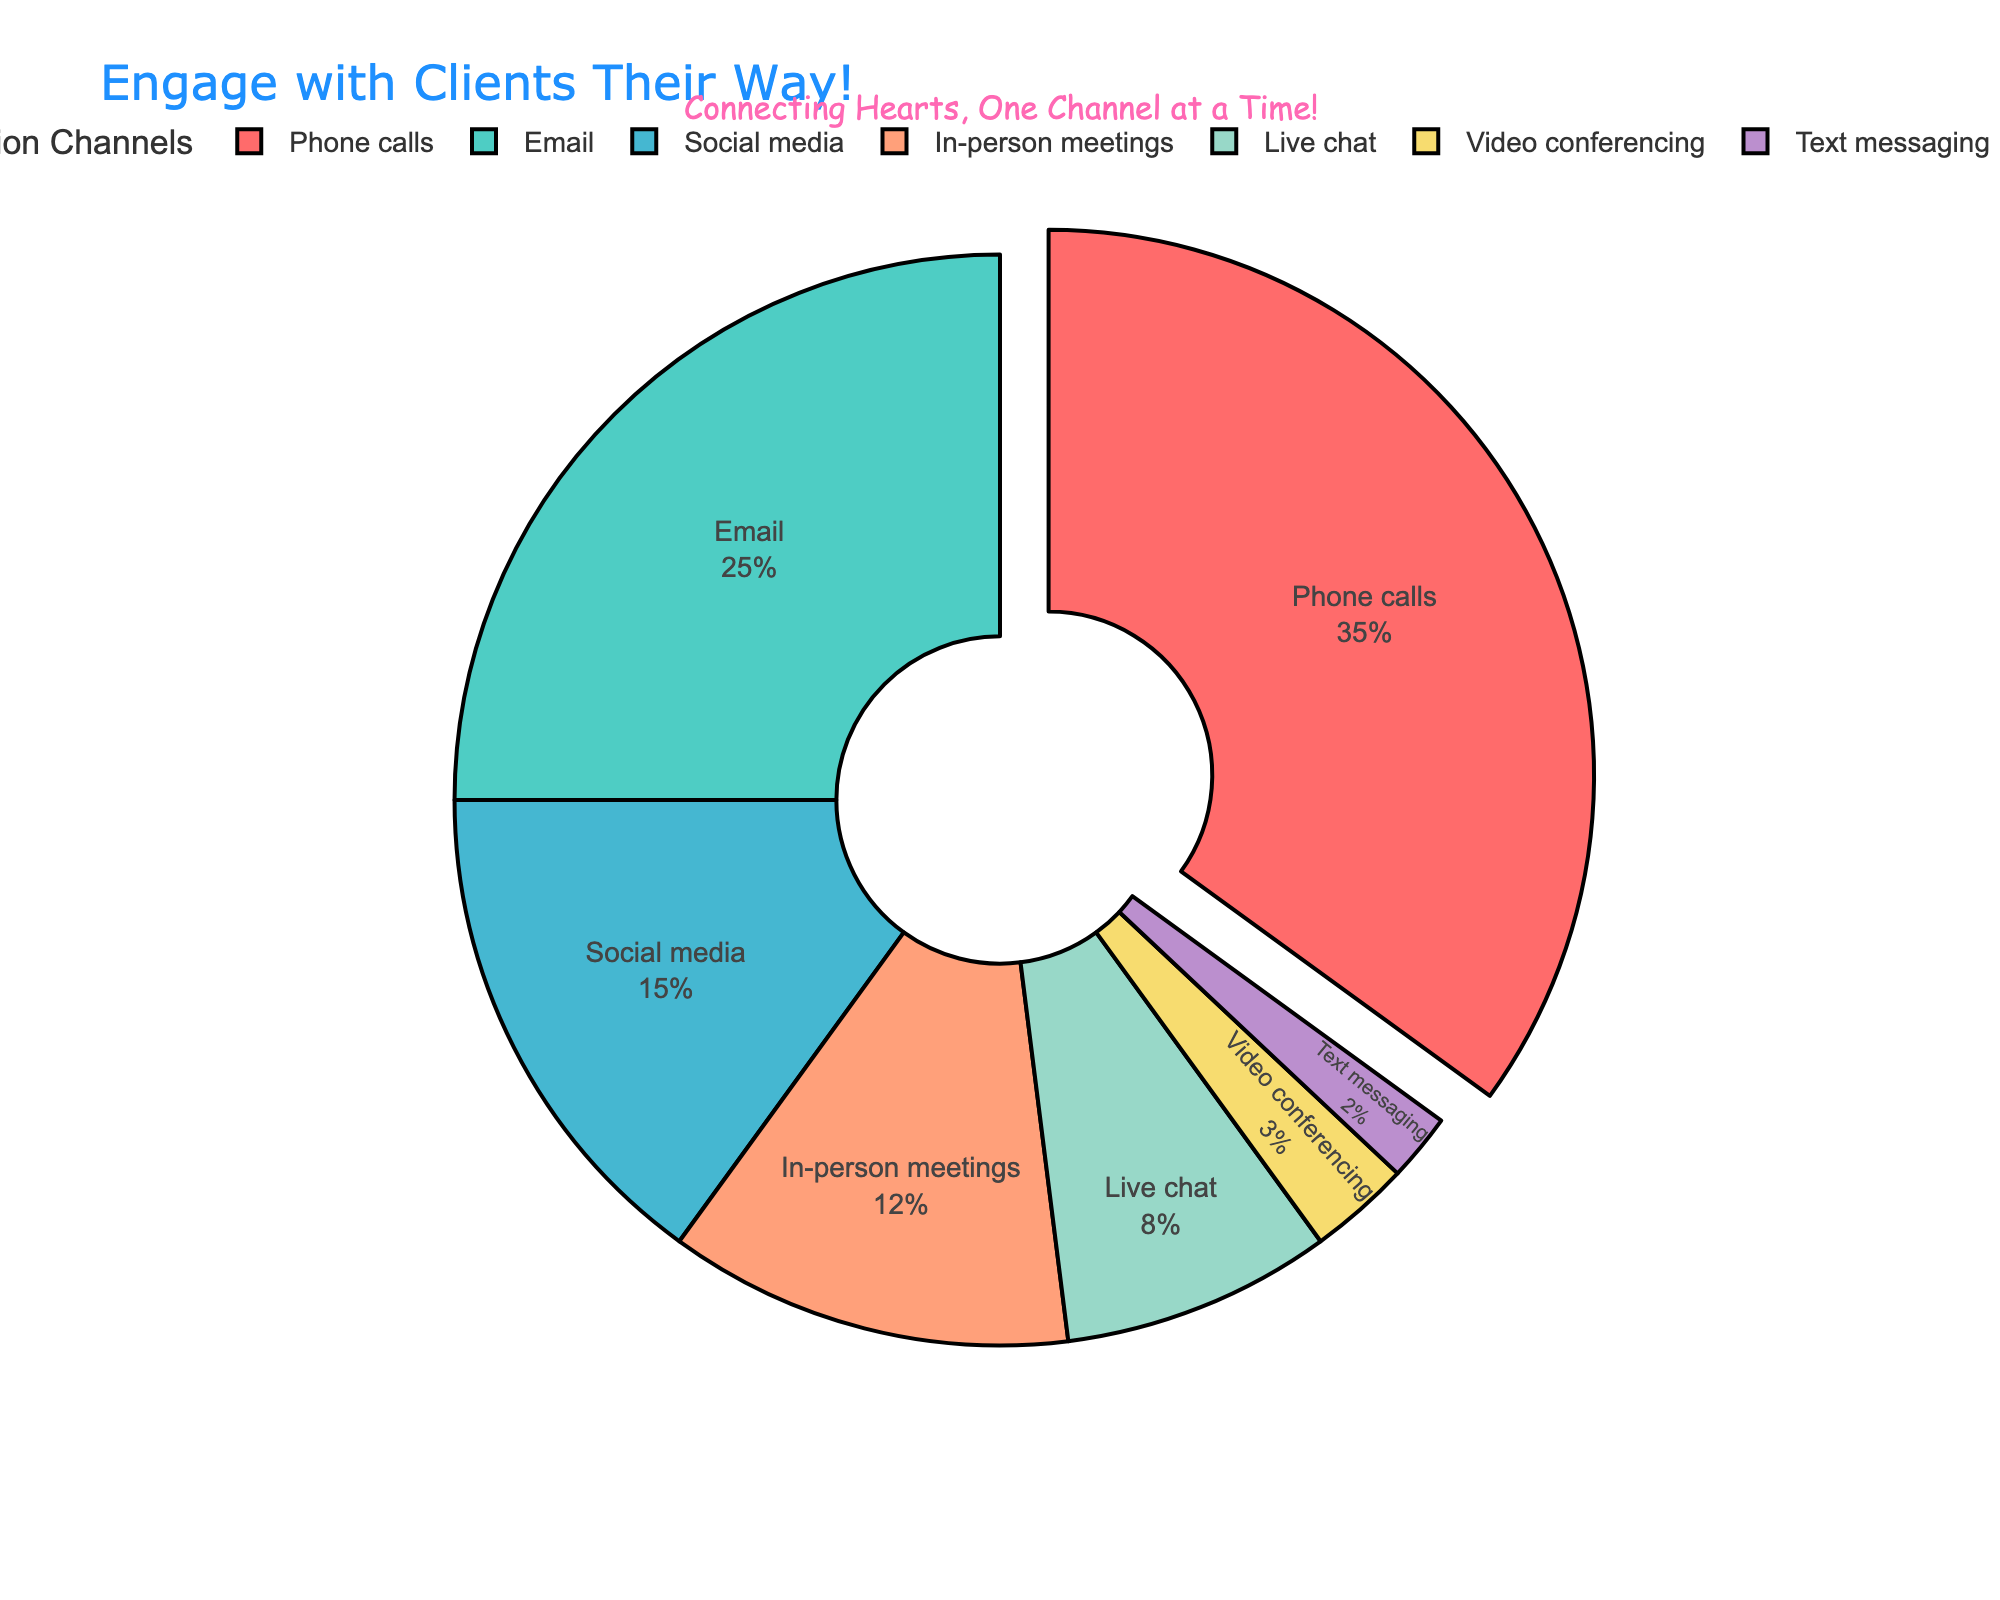Which channel is the most preferred by clients? The channel with the highest percentage in the pie chart is "Phone calls" at 35%.
Answer: Phone calls What is the combined percentage for Email and Social media? Email is 25% and Social media is 15%. Adding them together: 25 + 15 = 40%.
Answer: 40% Which channels combined make up less than 10% of the total? Channels with percentages are: Video conferencing (3%) and Text messaging (2%). Adding them: 3 + 2 = 5%.
Answer: Video conferencing and Text messaging How much more preferred is Phone calls compared to Live chat? Phone calls are 35% and Live chat is 8%. Subtracting them: 35 - 8 = 27%.
Answer: 27% Which channel has the smallest preference among clients? The channel with the lowest percentage in the pie chart is "Text messaging" at 2%.
Answer: Text messaging What is the percentage difference between the two least preferred channels? Video conferencing is 3% and Text messaging is 2%. Subtracting them: 3 - 2 = 1%.
Answer: 1% How many channels have a preference percentage below 10%? The channels with percentages below 10% are Live chat (8%), Video conferencing (3%), and Text messaging (2%). Counting them: 3 channels.
Answer: 3 channels Is Social media preferred more than Live chat? Social media is 15%, and Live chat is 8%. Since 15% is greater than 8%, Social media is more preferred.
Answer: Yes What percentage of clients prefer either Phone calls or Email? Phone calls are 35% and Email is 25%. Adding them together: 35 + 25 = 60%.
Answer: 60% Which channel is preferred almost equally to In-person meetings and Live chat combined? In-person meetings are 12% and Live chat is 8%. Adding them: 12 + 8 = 20%. The closest channel to 20% is Email at 25%, but this isn't equal. No exact match; both channels preference sum to 20%.
Answer: None 